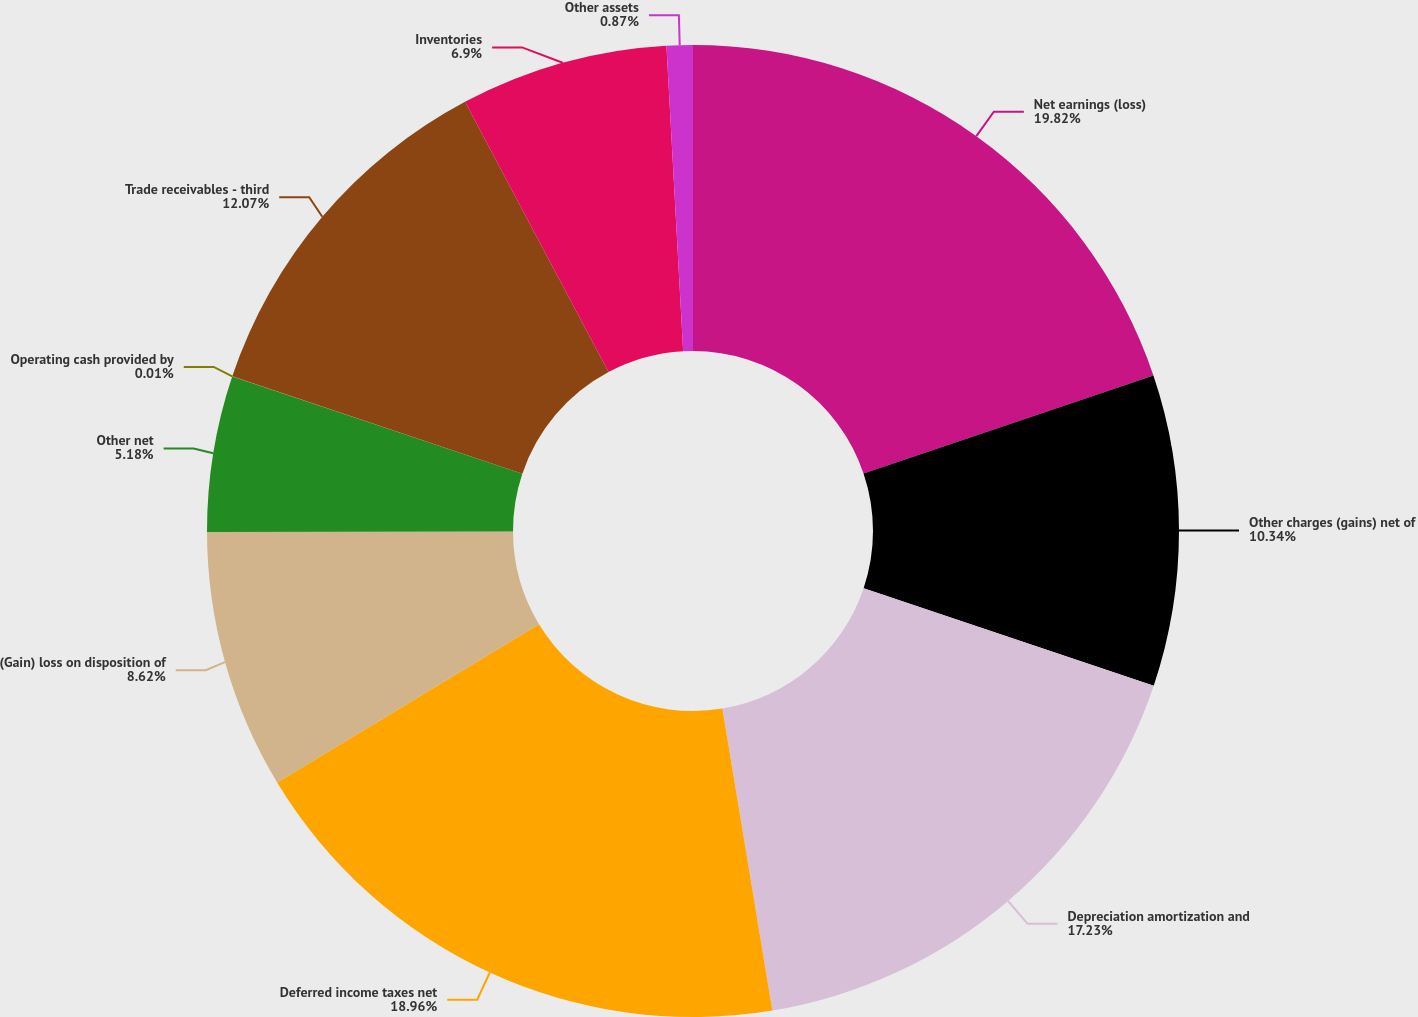<chart> <loc_0><loc_0><loc_500><loc_500><pie_chart><fcel>Net earnings (loss)<fcel>Other charges (gains) net of<fcel>Depreciation amortization and<fcel>Deferred income taxes net<fcel>(Gain) loss on disposition of<fcel>Other net<fcel>Operating cash provided by<fcel>Trade receivables - third<fcel>Inventories<fcel>Other assets<nl><fcel>19.81%<fcel>10.34%<fcel>17.23%<fcel>18.95%<fcel>8.62%<fcel>5.18%<fcel>0.01%<fcel>12.07%<fcel>6.9%<fcel>0.87%<nl></chart> 